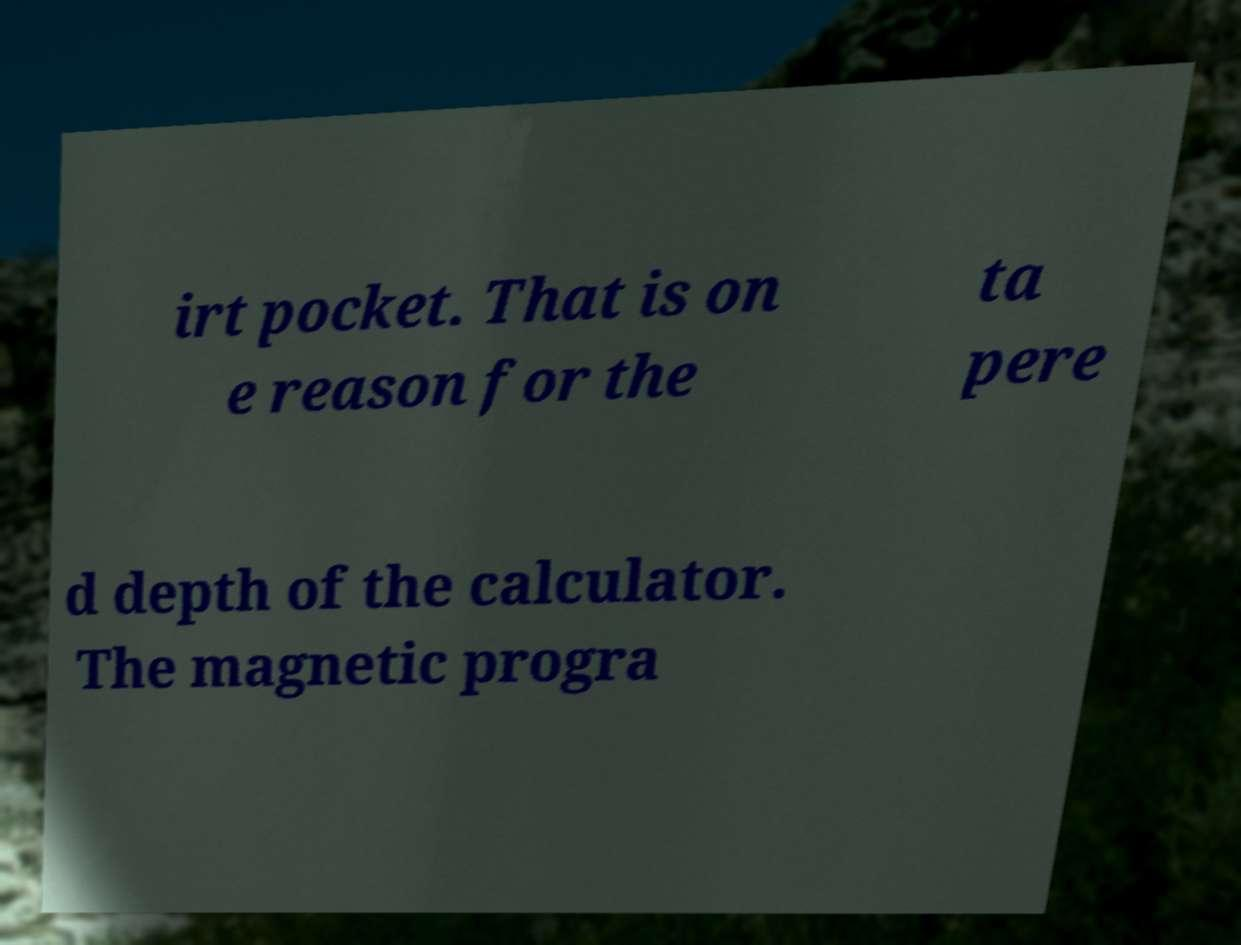For documentation purposes, I need the text within this image transcribed. Could you provide that? irt pocket. That is on e reason for the ta pere d depth of the calculator. The magnetic progra 